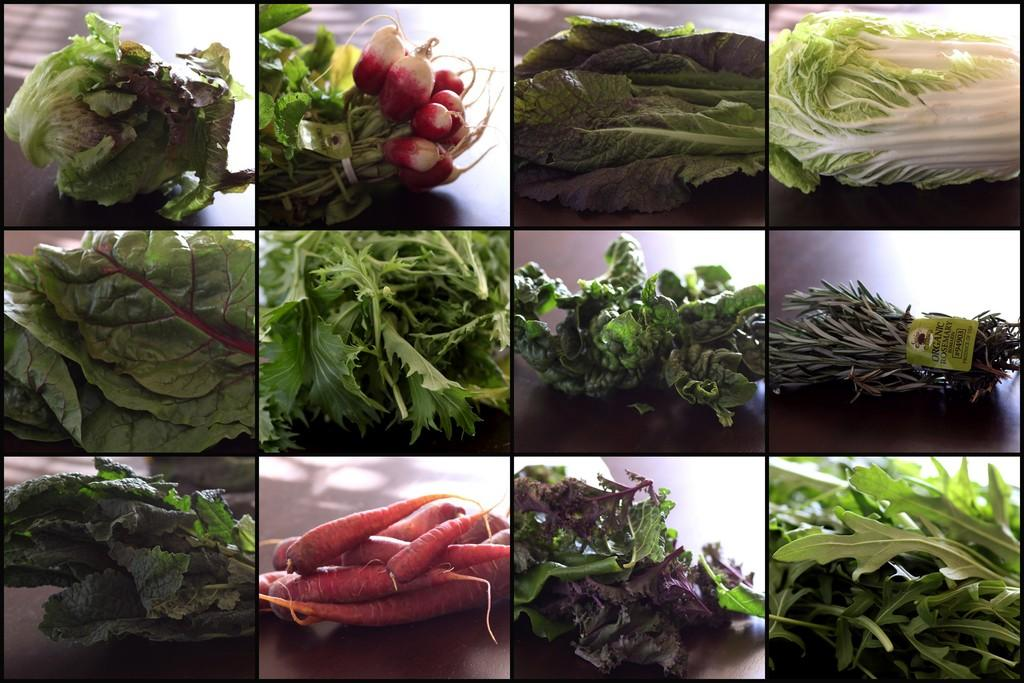What type of artwork is depicted in the image? The image is a collage of edited images. What kind of food items are featured in the collage? There are images of vegetables in the collage. Can you describe the types of vegetables shown in the collage? Leafy vegetables and non-leafy vegetables are visible in the images. How many chickens are present in the collage? There are no chickens present in the collage; it features images of vegetables. What type of learning material is depicted in the collage? The collage does not depict any learning materials; it is a collection of edited images of vegetables. 